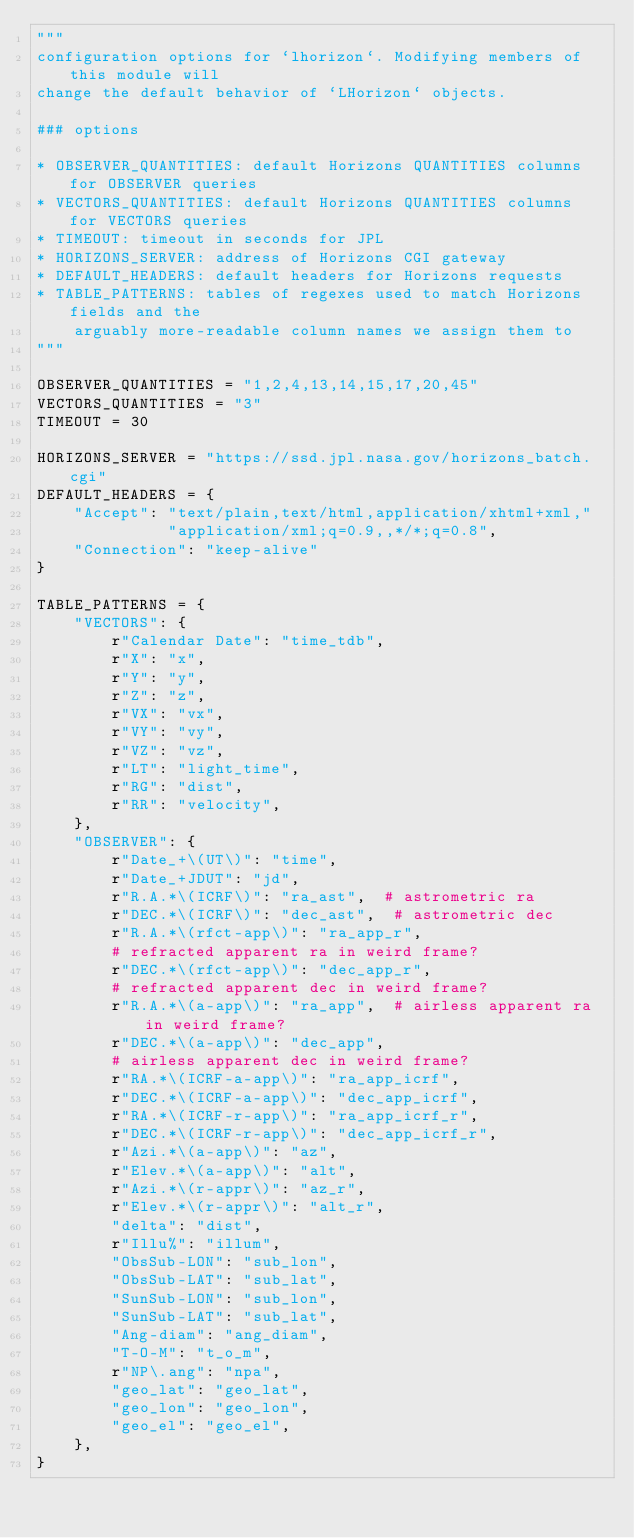Convert code to text. <code><loc_0><loc_0><loc_500><loc_500><_Python_>"""
configuration options for `lhorizon`. Modifying members of this module will
change the default behavior of `LHorizon` objects.

### options

* OBSERVER_QUANTITIES: default Horizons QUANTITIES columns for OBSERVER queries
* VECTORS_QUANTITIES: default Horizons QUANTITIES columns for VECTORS queries
* TIMEOUT: timeout in seconds for JPL
* HORIZONS_SERVER: address of Horizons CGI gateway
* DEFAULT_HEADERS: default headers for Horizons requests
* TABLE_PATTERNS: tables of regexes used to match Horizons fields and the
    arguably more-readable column names we assign them to
"""

OBSERVER_QUANTITIES = "1,2,4,13,14,15,17,20,45"
VECTORS_QUANTITIES = "3"
TIMEOUT = 30

HORIZONS_SERVER = "https://ssd.jpl.nasa.gov/horizons_batch.cgi"
DEFAULT_HEADERS = {
    "Accept": "text/plain,text/html,application/xhtml+xml,"
              "application/xml;q=0.9,,*/*;q=0.8",
    "Connection": "keep-alive"
}

TABLE_PATTERNS = {
    "VECTORS": {
        r"Calendar Date": "time_tdb",
        r"X": "x",
        r"Y": "y",
        r"Z": "z",
        r"VX": "vx",
        r"VY": "vy",
        r"VZ": "vz",
        r"LT": "light_time",
        r"RG": "dist",
        r"RR": "velocity",
    },
    "OBSERVER": {
        r"Date_+\(UT\)": "time",
        r"Date_+JDUT": "jd",
        r"R.A.*\(ICRF\)": "ra_ast",  # astrometric ra
        r"DEC.*\(ICRF\)": "dec_ast",  # astrometric dec
        r"R.A.*\(rfct-app\)": "ra_app_r",
        # refracted apparent ra in weird frame?
        r"DEC.*\(rfct-app\)": "dec_app_r",
        # refracted apparent dec in weird frame?
        r"R.A.*\(a-app\)": "ra_app",  # airless apparent ra in weird frame?
        r"DEC.*\(a-app\)": "dec_app",
        # airless apparent dec in weird frame?
        r"RA.*\(ICRF-a-app\)": "ra_app_icrf",
        r"DEC.*\(ICRF-a-app\)": "dec_app_icrf",
        r"RA.*\(ICRF-r-app\)": "ra_app_icrf_r",
        r"DEC.*\(ICRF-r-app\)": "dec_app_icrf_r",
        r"Azi.*\(a-app\)": "az",
        r"Elev.*\(a-app\)": "alt",
        r"Azi.*\(r-appr\)": "az_r",
        r"Elev.*\(r-appr\)": "alt_r",
        "delta": "dist",
        r"Illu%": "illum",
        "ObsSub-LON": "sub_lon",
        "ObsSub-LAT": "sub_lat",
        "SunSub-LON": "sub_lon",
        "SunSub-LAT": "sub_lat",
        "Ang-diam": "ang_diam",
        "T-O-M": "t_o_m",
        r"NP\.ang": "npa",
        "geo_lat": "geo_lat",
        "geo_lon": "geo_lon",
        "geo_el": "geo_el",
    },
}
</code> 